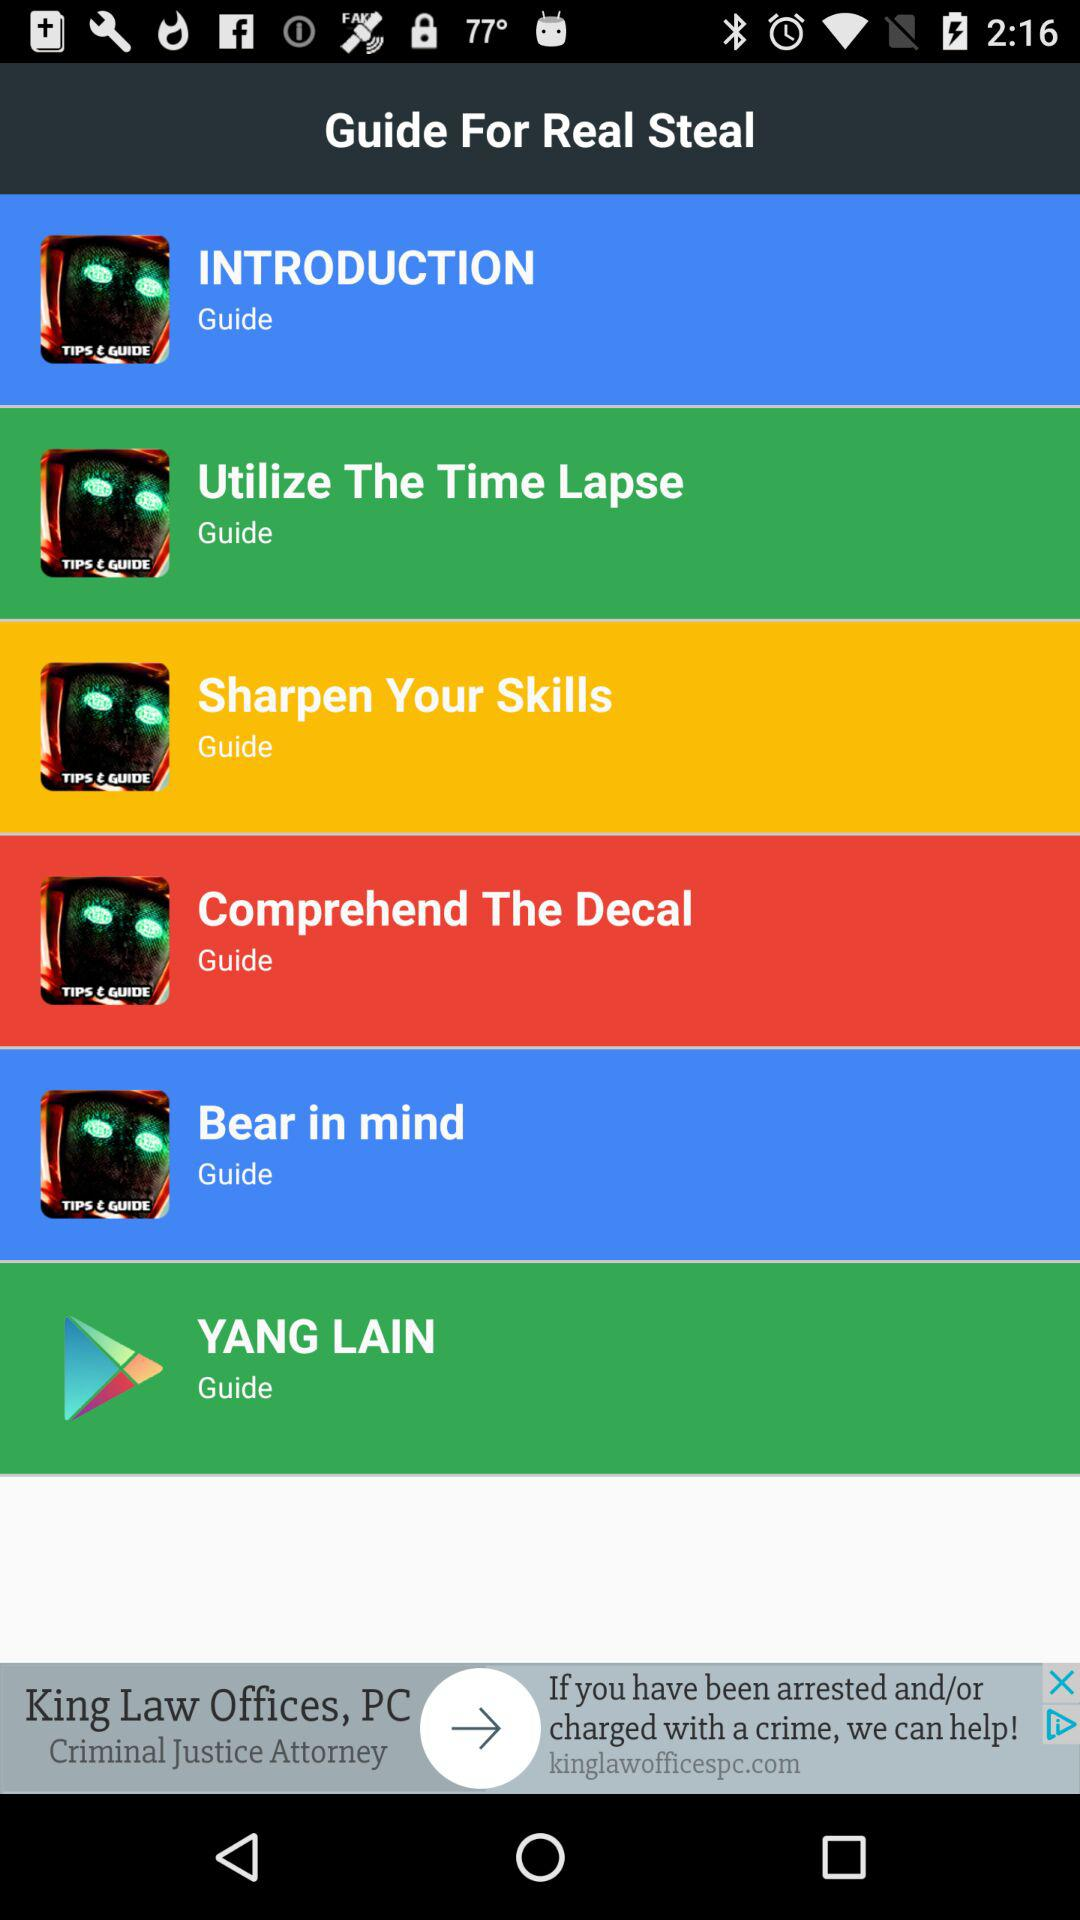Which guide is selected?
When the provided information is insufficient, respond with <no answer>. <no answer> 